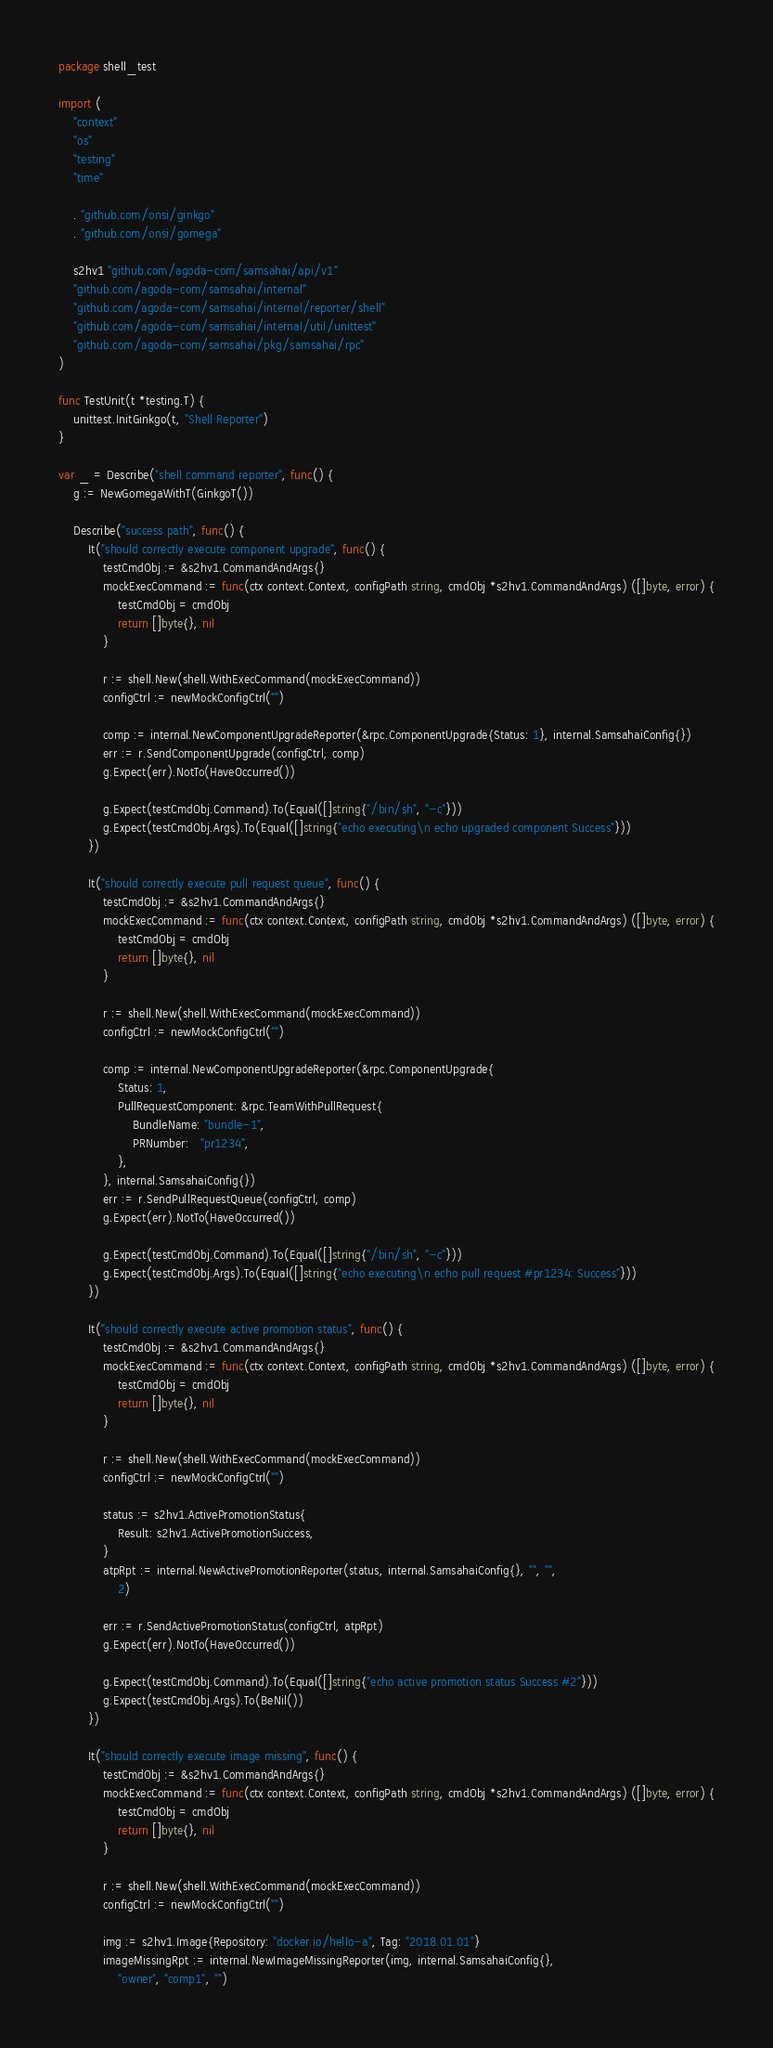Convert code to text. <code><loc_0><loc_0><loc_500><loc_500><_Go_>package shell_test

import (
	"context"
	"os"
	"testing"
	"time"

	. "github.com/onsi/ginkgo"
	. "github.com/onsi/gomega"

	s2hv1 "github.com/agoda-com/samsahai/api/v1"
	"github.com/agoda-com/samsahai/internal"
	"github.com/agoda-com/samsahai/internal/reporter/shell"
	"github.com/agoda-com/samsahai/internal/util/unittest"
	"github.com/agoda-com/samsahai/pkg/samsahai/rpc"
)

func TestUnit(t *testing.T) {
	unittest.InitGinkgo(t, "Shell Reporter")
}

var _ = Describe("shell command reporter", func() {
	g := NewGomegaWithT(GinkgoT())

	Describe("success path", func() {
		It("should correctly execute component upgrade", func() {
			testCmdObj := &s2hv1.CommandAndArgs{}
			mockExecCommand := func(ctx context.Context, configPath string, cmdObj *s2hv1.CommandAndArgs) ([]byte, error) {
				testCmdObj = cmdObj
				return []byte{}, nil
			}

			r := shell.New(shell.WithExecCommand(mockExecCommand))
			configCtrl := newMockConfigCtrl("")

			comp := internal.NewComponentUpgradeReporter(&rpc.ComponentUpgrade{Status: 1}, internal.SamsahaiConfig{})
			err := r.SendComponentUpgrade(configCtrl, comp)
			g.Expect(err).NotTo(HaveOccurred())

			g.Expect(testCmdObj.Command).To(Equal([]string{"/bin/sh", "-c"}))
			g.Expect(testCmdObj.Args).To(Equal([]string{"echo executing\n echo upgraded component Success"}))
		})

		It("should correctly execute pull request queue", func() {
			testCmdObj := &s2hv1.CommandAndArgs{}
			mockExecCommand := func(ctx context.Context, configPath string, cmdObj *s2hv1.CommandAndArgs) ([]byte, error) {
				testCmdObj = cmdObj
				return []byte{}, nil
			}

			r := shell.New(shell.WithExecCommand(mockExecCommand))
			configCtrl := newMockConfigCtrl("")

			comp := internal.NewComponentUpgradeReporter(&rpc.ComponentUpgrade{
				Status: 1,
				PullRequestComponent: &rpc.TeamWithPullRequest{
					BundleName: "bundle-1",
					PRNumber:   "pr1234",
				},
			}, internal.SamsahaiConfig{})
			err := r.SendPullRequestQueue(configCtrl, comp)
			g.Expect(err).NotTo(HaveOccurred())

			g.Expect(testCmdObj.Command).To(Equal([]string{"/bin/sh", "-c"}))
			g.Expect(testCmdObj.Args).To(Equal([]string{"echo executing\n echo pull request #pr1234: Success"}))
		})

		It("should correctly execute active promotion status", func() {
			testCmdObj := &s2hv1.CommandAndArgs{}
			mockExecCommand := func(ctx context.Context, configPath string, cmdObj *s2hv1.CommandAndArgs) ([]byte, error) {
				testCmdObj = cmdObj
				return []byte{}, nil
			}

			r := shell.New(shell.WithExecCommand(mockExecCommand))
			configCtrl := newMockConfigCtrl("")

			status := s2hv1.ActivePromotionStatus{
				Result: s2hv1.ActivePromotionSuccess,
			}
			atpRpt := internal.NewActivePromotionReporter(status, internal.SamsahaiConfig{}, "", "",
				2)

			err := r.SendActivePromotionStatus(configCtrl, atpRpt)
			g.Expect(err).NotTo(HaveOccurred())

			g.Expect(testCmdObj.Command).To(Equal([]string{"echo active promotion status Success #2"}))
			g.Expect(testCmdObj.Args).To(BeNil())
		})

		It("should correctly execute image missing", func() {
			testCmdObj := &s2hv1.CommandAndArgs{}
			mockExecCommand := func(ctx context.Context, configPath string, cmdObj *s2hv1.CommandAndArgs) ([]byte, error) {
				testCmdObj = cmdObj
				return []byte{}, nil
			}

			r := shell.New(shell.WithExecCommand(mockExecCommand))
			configCtrl := newMockConfigCtrl("")

			img := s2hv1.Image{Repository: "docker.io/hello-a", Tag: "2018.01.01"}
			imageMissingRpt := internal.NewImageMissingReporter(img, internal.SamsahaiConfig{},
				"owner", "comp1", "")</code> 